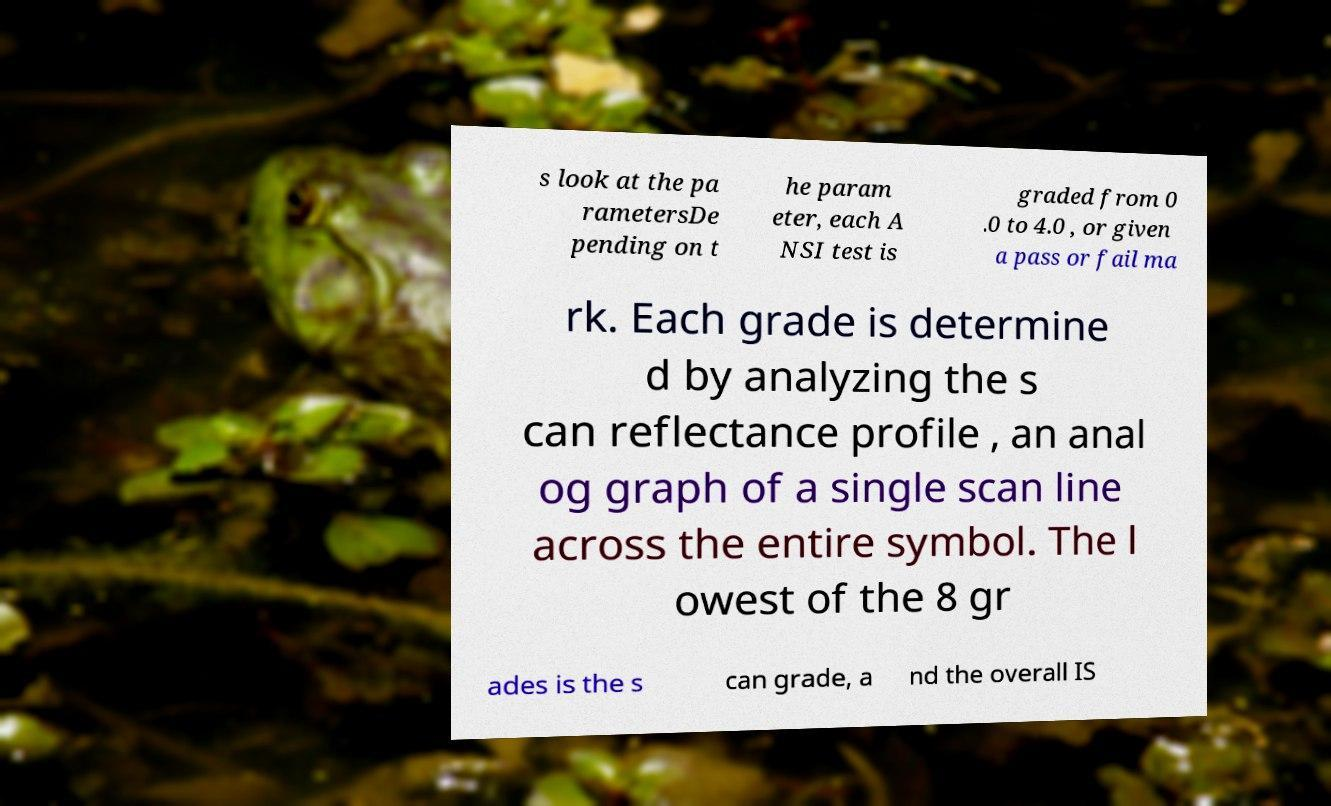What messages or text are displayed in this image? I need them in a readable, typed format. s look at the pa rametersDe pending on t he param eter, each A NSI test is graded from 0 .0 to 4.0 , or given a pass or fail ma rk. Each grade is determine d by analyzing the s can reflectance profile , an anal og graph of a single scan line across the entire symbol. The l owest of the 8 gr ades is the s can grade, a nd the overall IS 